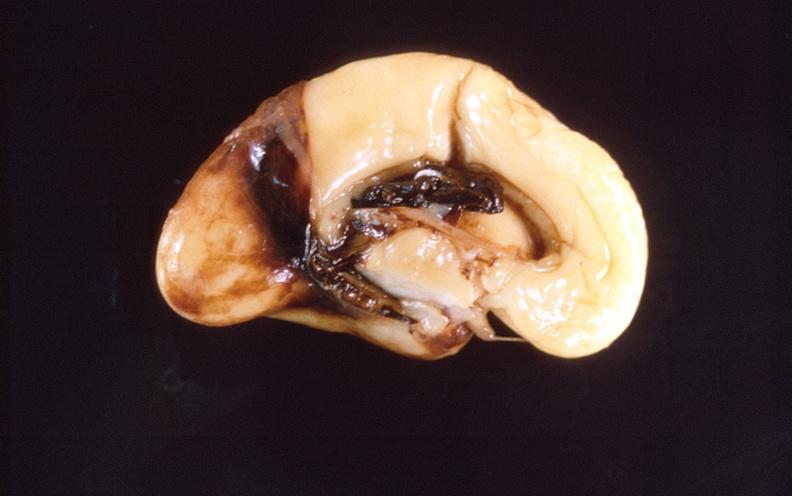what does this image show?
Answer the question using a single word or phrase. Intraventricular hemorrhage 